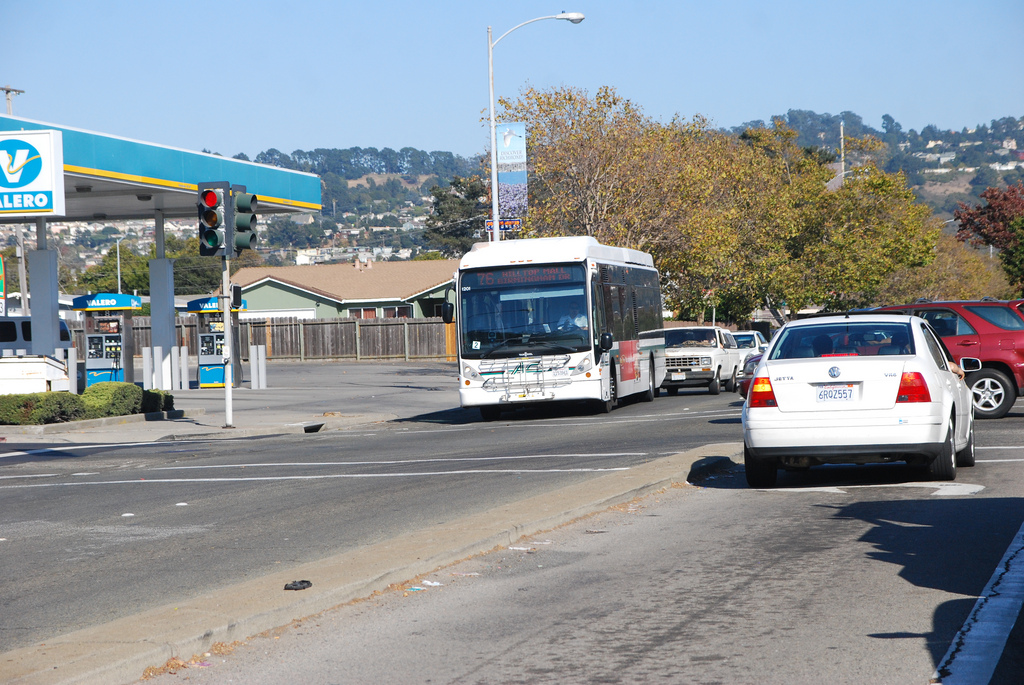Is the truck the same color as the gas pump? No, the truck is multicolored, primarily white, while the gas pump sports a white color with Valero's signature blue branding. 